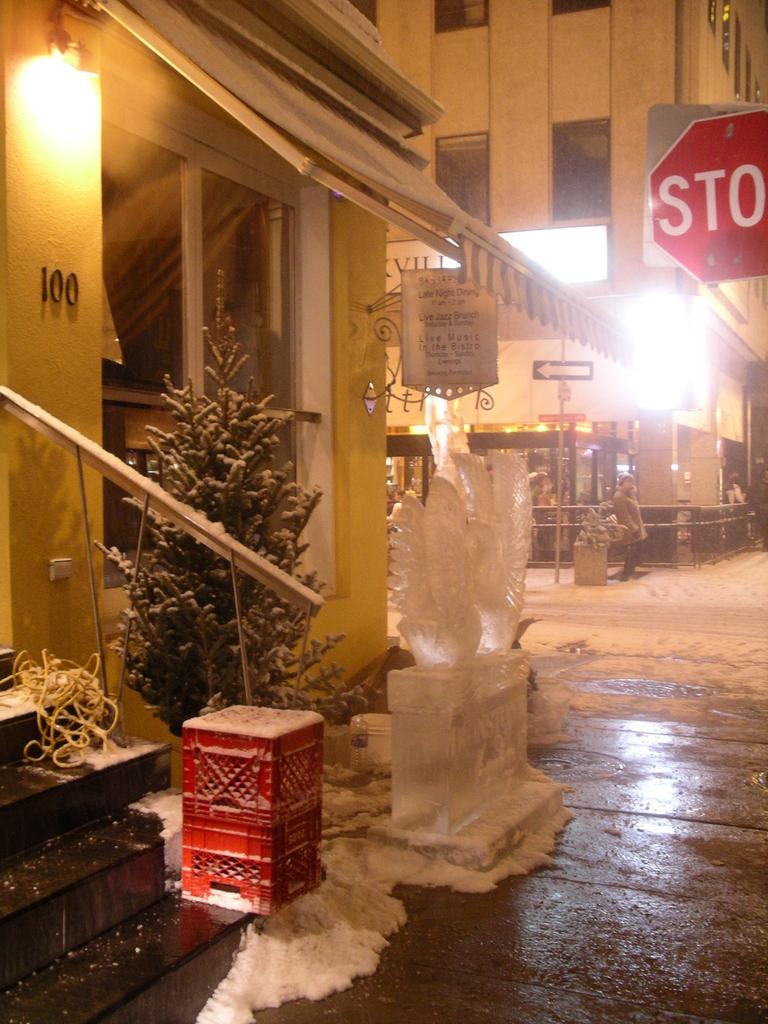What type of structures can be seen in the image? There are buildings in the image. What is located in front of the buildings? There is a tree and a box in front of the buildings. Can you describe any other objects or features in the image? There is a sculpture of birds in the image. What type of poison is being used to protect the buildings in the image? There is no mention of poison in the image; it is not present. 